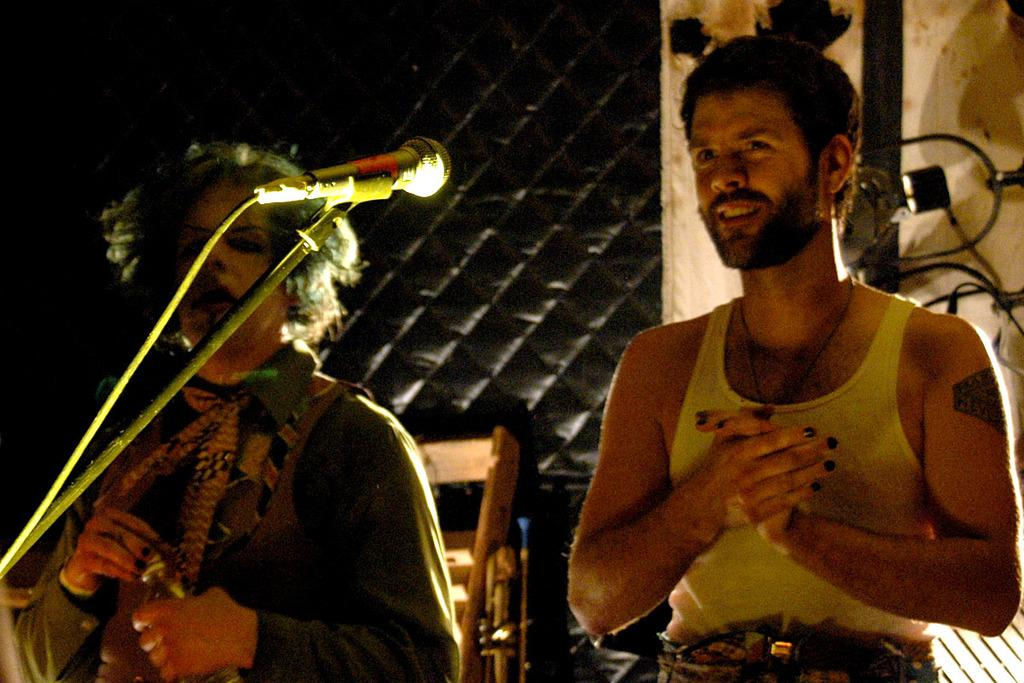How many people are present in the image? There are two people in the image. What can be seen in the background of the image? There is a mic and a wooden object in the background of the image. What type of maid is visible in the image? There is no maid present in the image. How many eggs are visible in the image? There are no eggs present in the image. 